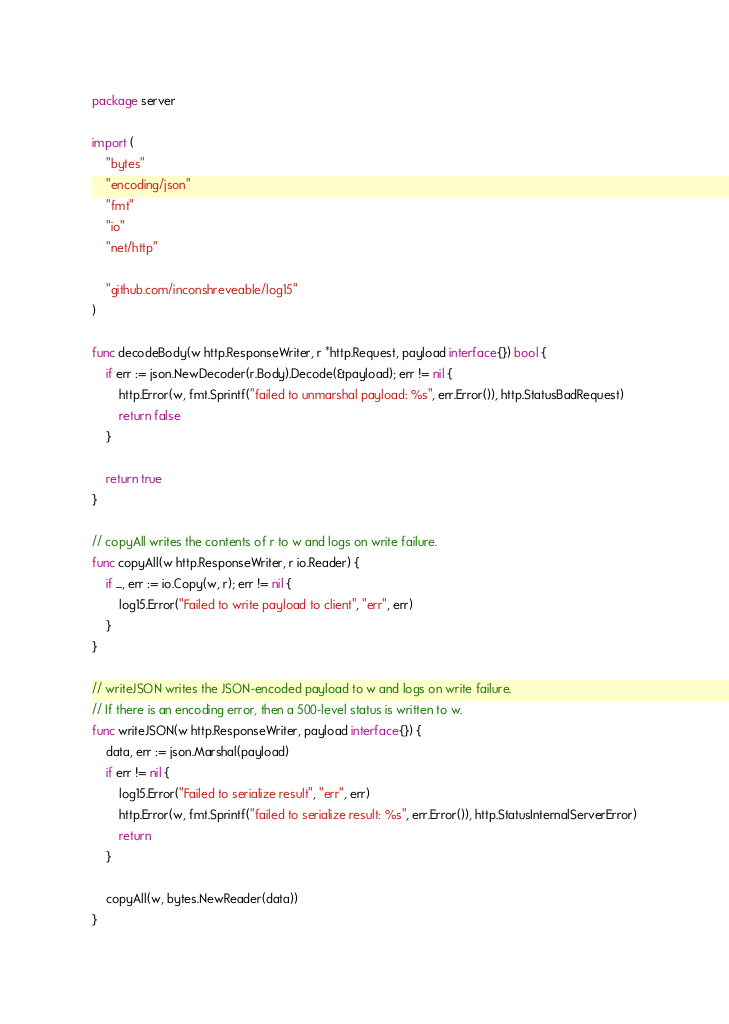<code> <loc_0><loc_0><loc_500><loc_500><_Go_>package server

import (
	"bytes"
	"encoding/json"
	"fmt"
	"io"
	"net/http"

	"github.com/inconshreveable/log15"
)

func decodeBody(w http.ResponseWriter, r *http.Request, payload interface{}) bool {
	if err := json.NewDecoder(r.Body).Decode(&payload); err != nil {
		http.Error(w, fmt.Sprintf("failed to unmarshal payload: %s", err.Error()), http.StatusBadRequest)
		return false
	}

	return true
}

// copyAll writes the contents of r to w and logs on write failure.
func copyAll(w http.ResponseWriter, r io.Reader) {
	if _, err := io.Copy(w, r); err != nil {
		log15.Error("Failed to write payload to client", "err", err)
	}
}

// writeJSON writes the JSON-encoded payload to w and logs on write failure.
// If there is an encoding error, then a 500-level status is written to w.
func writeJSON(w http.ResponseWriter, payload interface{}) {
	data, err := json.Marshal(payload)
	if err != nil {
		log15.Error("Failed to serialize result", "err", err)
		http.Error(w, fmt.Sprintf("failed to serialize result: %s", err.Error()), http.StatusInternalServerError)
		return
	}

	copyAll(w, bytes.NewReader(data))
}
</code> 